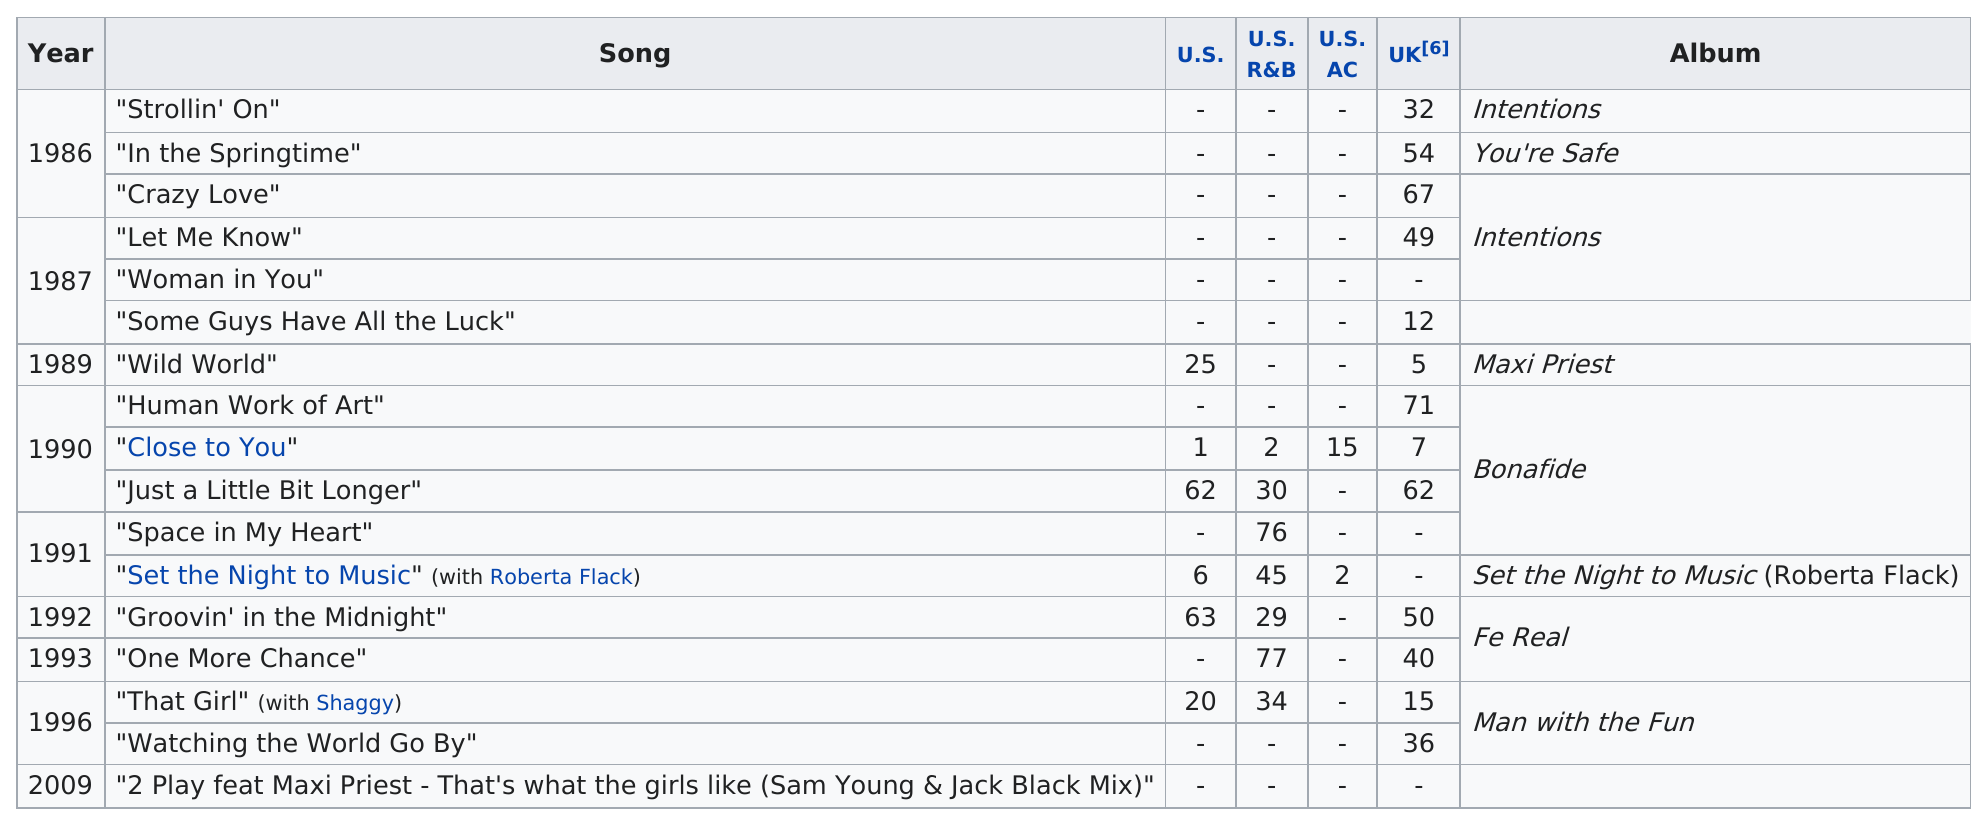Outline some significant characteristics in this image. The previous year of 1987 had 3 songs. There were three songs that charted at a position above the tenth on at least one chart. There were a total of 13 songs that charted in the United Kingdom. The album that had more, "bonafide" or "intentions"? The answer is clear, "bonafide" had more. The highest position a song from the album "bonafide" reached on any chart is 1. 